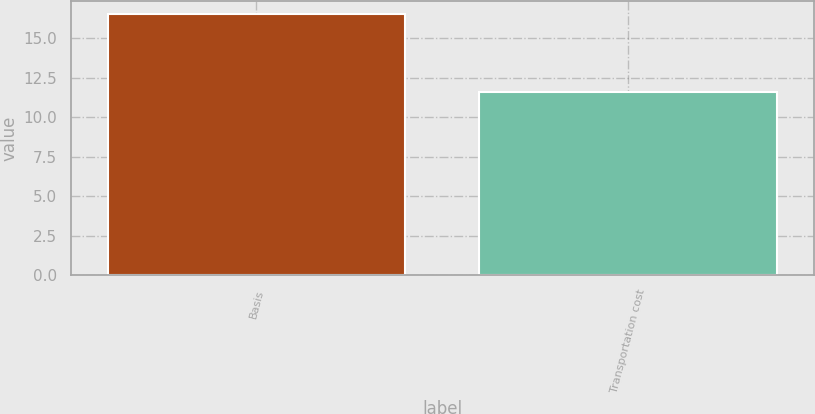Convert chart to OTSL. <chart><loc_0><loc_0><loc_500><loc_500><bar_chart><fcel>Basis<fcel>Transportation cost<nl><fcel>16.5<fcel>11.6<nl></chart> 